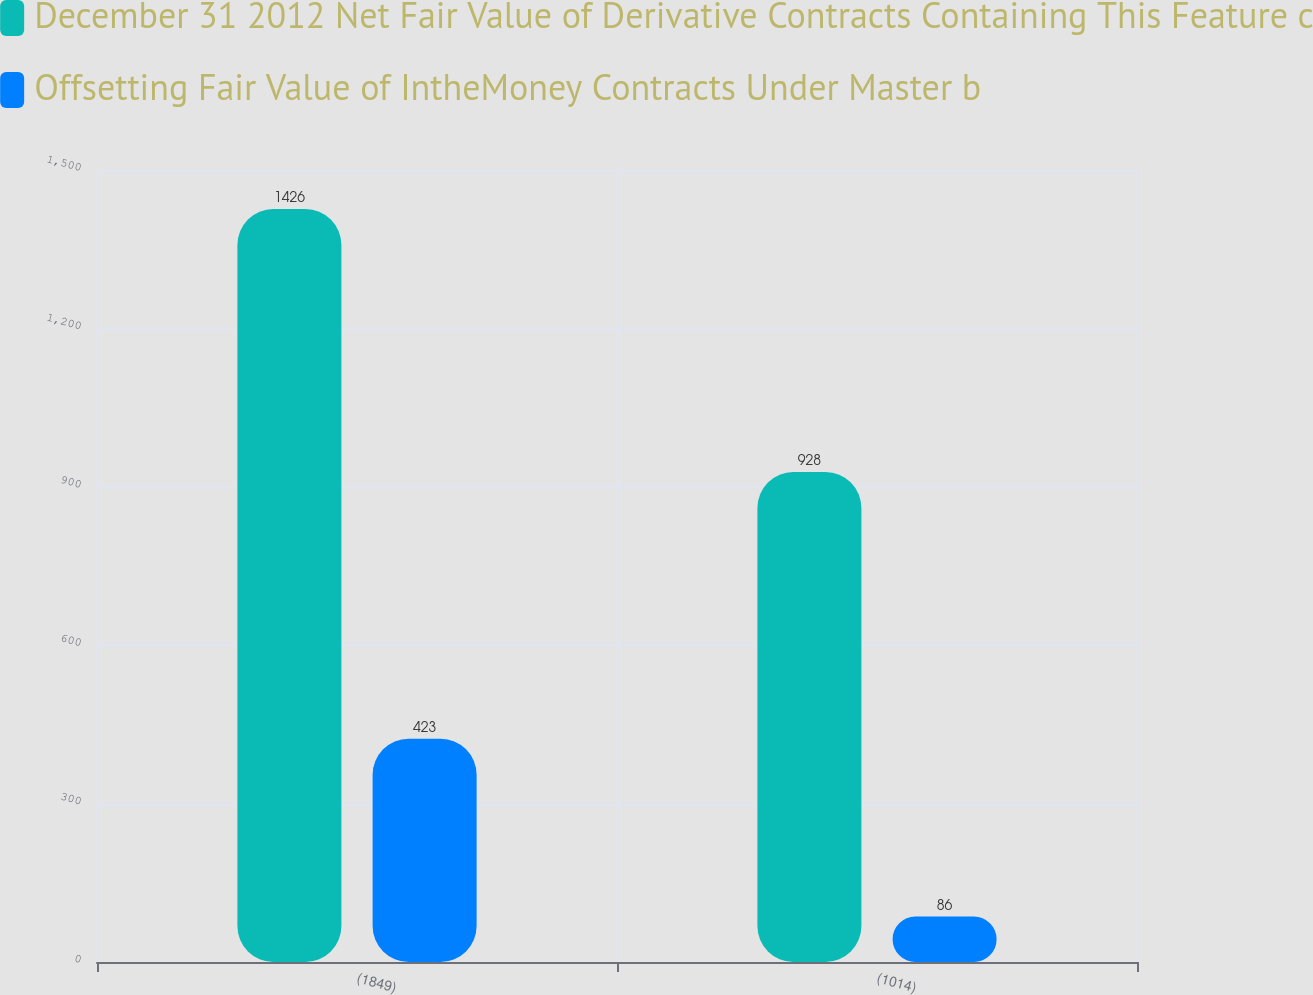Convert chart. <chart><loc_0><loc_0><loc_500><loc_500><stacked_bar_chart><ecel><fcel>(1849)<fcel>(1014)<nl><fcel>December 31 2012 Net Fair Value of Derivative Contracts Containing This Feature c<fcel>1426<fcel>928<nl><fcel>Offsetting Fair Value of IntheMoney Contracts Under Master b<fcel>423<fcel>86<nl></chart> 